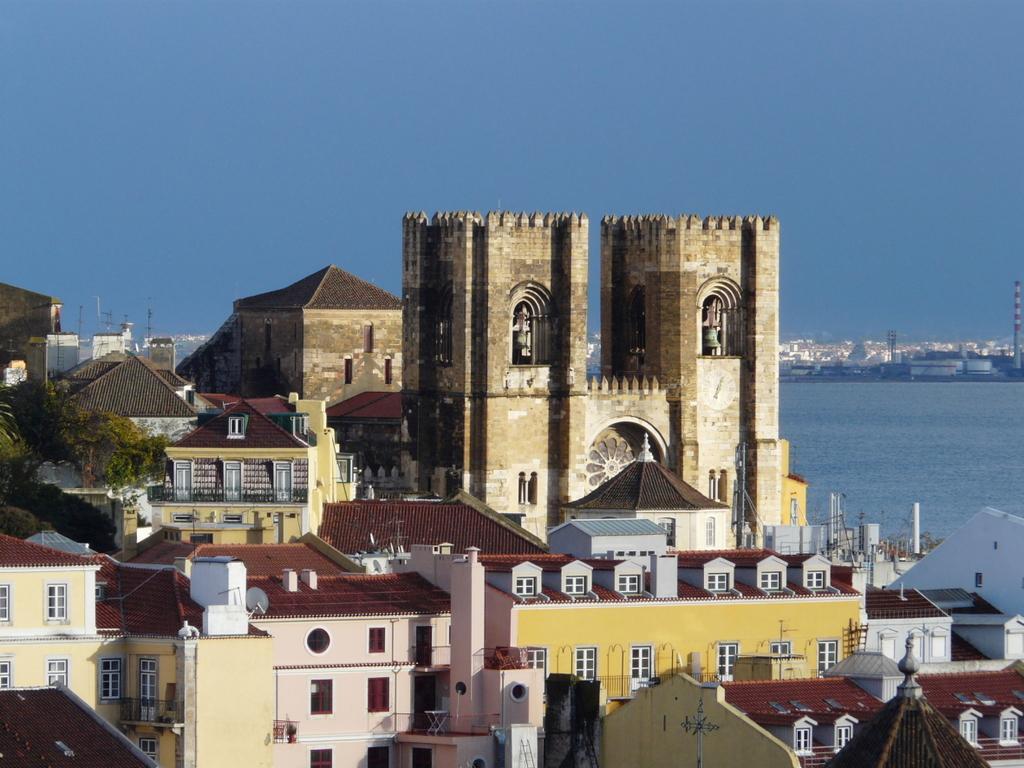Could you give a brief overview of what you see in this image? In this image I can see number of buildings in the front. On the right side of this image I can see water and on the left side I can see a tree. I can also see the sky in the background. 